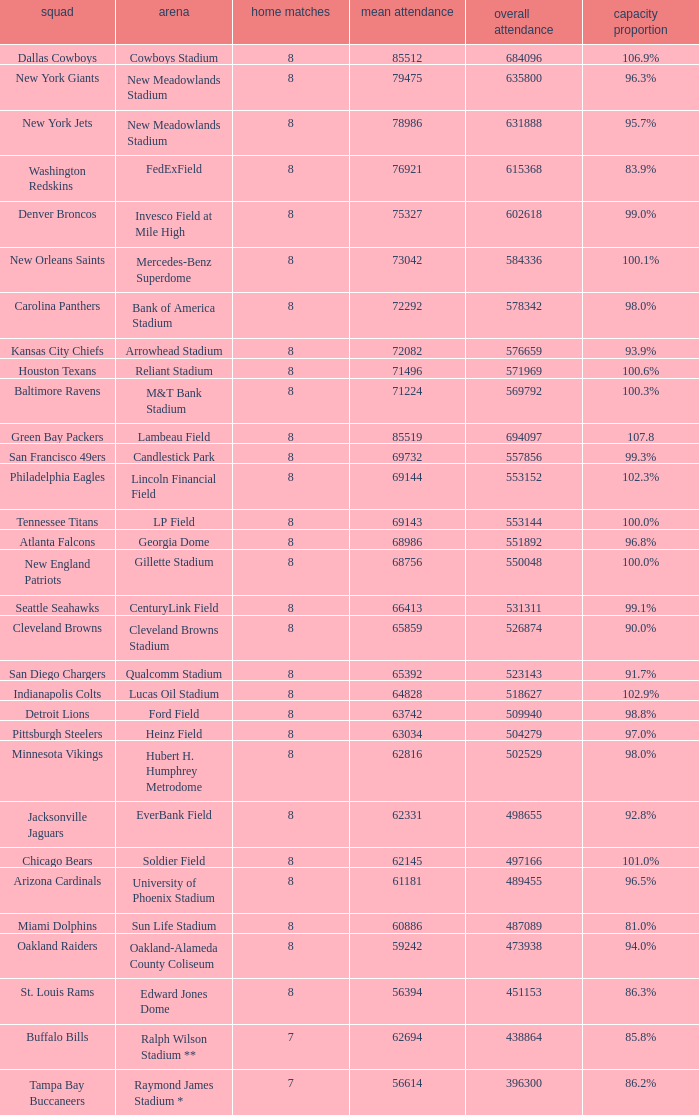What is the name of the stadium when the capacity percentage is 83.9% FedExField. 